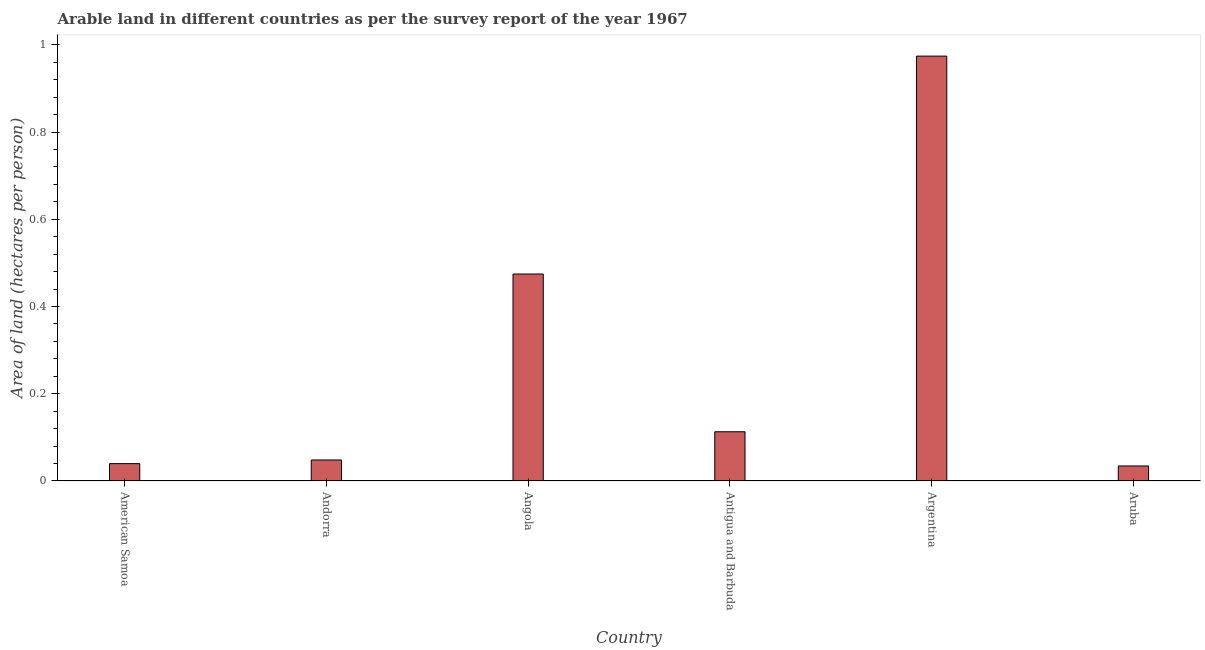Does the graph contain any zero values?
Your response must be concise. No. What is the title of the graph?
Your answer should be very brief. Arable land in different countries as per the survey report of the year 1967. What is the label or title of the X-axis?
Give a very brief answer. Country. What is the label or title of the Y-axis?
Provide a short and direct response. Area of land (hectares per person). What is the area of arable land in Aruba?
Keep it short and to the point. 0.03. Across all countries, what is the maximum area of arable land?
Make the answer very short. 0.97. Across all countries, what is the minimum area of arable land?
Provide a short and direct response. 0.03. In which country was the area of arable land minimum?
Provide a succinct answer. Aruba. What is the sum of the area of arable land?
Provide a succinct answer. 1.68. What is the difference between the area of arable land in American Samoa and Andorra?
Provide a short and direct response. -0.01. What is the average area of arable land per country?
Provide a short and direct response. 0.28. What is the median area of arable land?
Offer a terse response. 0.08. What is the ratio of the area of arable land in Andorra to that in Argentina?
Make the answer very short. 0.05. Is the area of arable land in Andorra less than that in Aruba?
Keep it short and to the point. No. What is the difference between the highest and the second highest area of arable land?
Provide a succinct answer. 0.5. What is the difference between the highest and the lowest area of arable land?
Keep it short and to the point. 0.94. In how many countries, is the area of arable land greater than the average area of arable land taken over all countries?
Offer a terse response. 2. What is the difference between two consecutive major ticks on the Y-axis?
Your response must be concise. 0.2. What is the Area of land (hectares per person) in American Samoa?
Make the answer very short. 0.04. What is the Area of land (hectares per person) of Andorra?
Give a very brief answer. 0.05. What is the Area of land (hectares per person) of Angola?
Ensure brevity in your answer.  0.47. What is the Area of land (hectares per person) in Antigua and Barbuda?
Your answer should be very brief. 0.11. What is the Area of land (hectares per person) of Argentina?
Make the answer very short. 0.97. What is the Area of land (hectares per person) in Aruba?
Your response must be concise. 0.03. What is the difference between the Area of land (hectares per person) in American Samoa and Andorra?
Make the answer very short. -0.01. What is the difference between the Area of land (hectares per person) in American Samoa and Angola?
Your response must be concise. -0.43. What is the difference between the Area of land (hectares per person) in American Samoa and Antigua and Barbuda?
Make the answer very short. -0.07. What is the difference between the Area of land (hectares per person) in American Samoa and Argentina?
Make the answer very short. -0.93. What is the difference between the Area of land (hectares per person) in American Samoa and Aruba?
Your answer should be compact. 0.01. What is the difference between the Area of land (hectares per person) in Andorra and Angola?
Provide a short and direct response. -0.43. What is the difference between the Area of land (hectares per person) in Andorra and Antigua and Barbuda?
Offer a very short reply. -0.06. What is the difference between the Area of land (hectares per person) in Andorra and Argentina?
Your response must be concise. -0.93. What is the difference between the Area of land (hectares per person) in Andorra and Aruba?
Your response must be concise. 0.01. What is the difference between the Area of land (hectares per person) in Angola and Antigua and Barbuda?
Your answer should be very brief. 0.36. What is the difference between the Area of land (hectares per person) in Angola and Argentina?
Your answer should be compact. -0.5. What is the difference between the Area of land (hectares per person) in Angola and Aruba?
Provide a succinct answer. 0.44. What is the difference between the Area of land (hectares per person) in Antigua and Barbuda and Argentina?
Provide a short and direct response. -0.86. What is the difference between the Area of land (hectares per person) in Antigua and Barbuda and Aruba?
Make the answer very short. 0.08. What is the difference between the Area of land (hectares per person) in Argentina and Aruba?
Provide a short and direct response. 0.94. What is the ratio of the Area of land (hectares per person) in American Samoa to that in Andorra?
Give a very brief answer. 0.83. What is the ratio of the Area of land (hectares per person) in American Samoa to that in Angola?
Your answer should be compact. 0.08. What is the ratio of the Area of land (hectares per person) in American Samoa to that in Antigua and Barbuda?
Provide a short and direct response. 0.35. What is the ratio of the Area of land (hectares per person) in American Samoa to that in Argentina?
Offer a terse response. 0.04. What is the ratio of the Area of land (hectares per person) in American Samoa to that in Aruba?
Give a very brief answer. 1.16. What is the ratio of the Area of land (hectares per person) in Andorra to that in Angola?
Provide a short and direct response. 0.1. What is the ratio of the Area of land (hectares per person) in Andorra to that in Antigua and Barbuda?
Your answer should be very brief. 0.43. What is the ratio of the Area of land (hectares per person) in Andorra to that in Argentina?
Offer a terse response. 0.05. What is the ratio of the Area of land (hectares per person) in Andorra to that in Aruba?
Your answer should be compact. 1.4. What is the ratio of the Area of land (hectares per person) in Angola to that in Antigua and Barbuda?
Your response must be concise. 4.2. What is the ratio of the Area of land (hectares per person) in Angola to that in Argentina?
Your answer should be very brief. 0.49. What is the ratio of the Area of land (hectares per person) in Angola to that in Aruba?
Offer a terse response. 13.78. What is the ratio of the Area of land (hectares per person) in Antigua and Barbuda to that in Argentina?
Keep it short and to the point. 0.12. What is the ratio of the Area of land (hectares per person) in Antigua and Barbuda to that in Aruba?
Your answer should be very brief. 3.28. What is the ratio of the Area of land (hectares per person) in Argentina to that in Aruba?
Ensure brevity in your answer.  28.28. 